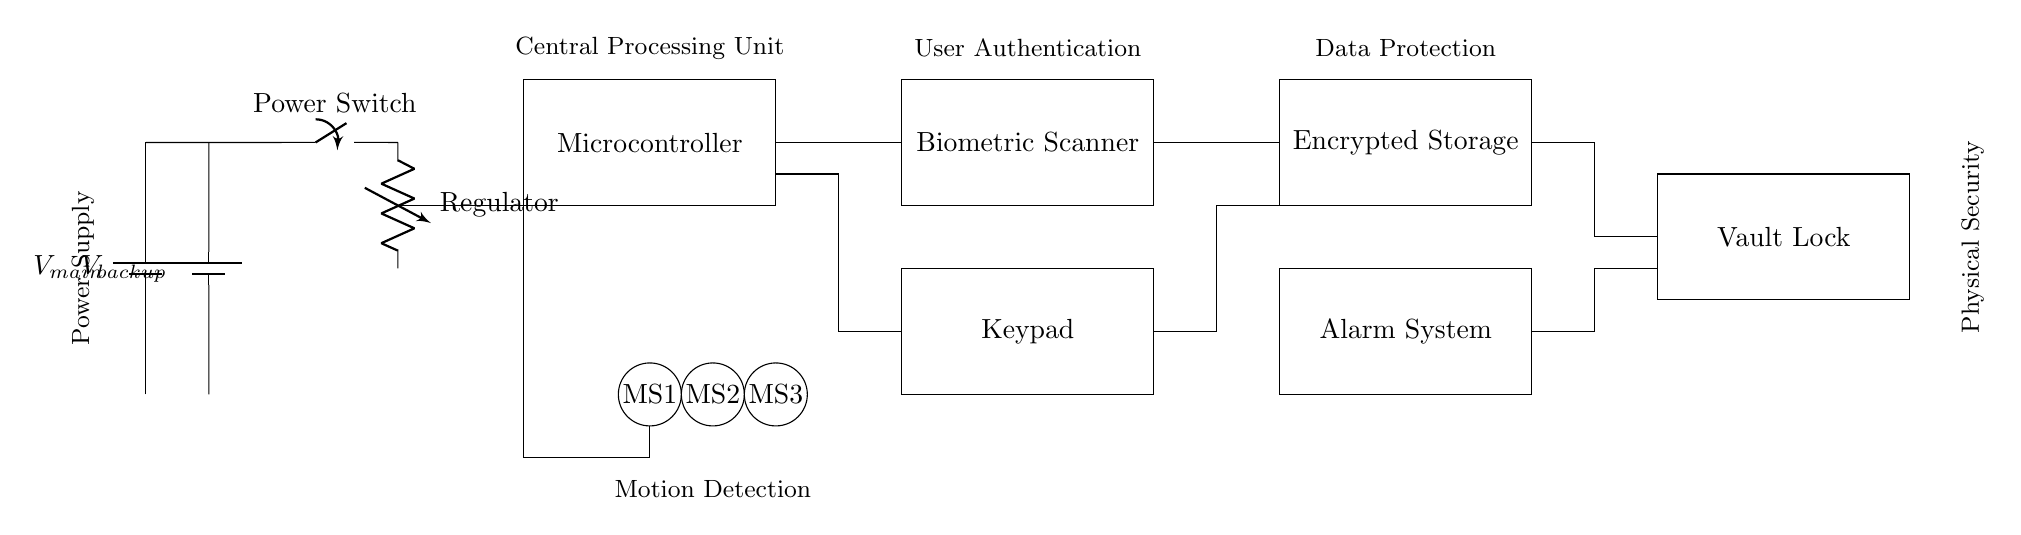What is the purpose of the microcontroller in this circuit? The microcontroller is used for processing and controlling the various components of the multi-layered security system, such as managing inputs from the biometric scanner and keypad, as well as dictating responses to authentication attempts.
Answer: Control and processing What are the two power supplies included in the circuit? The circuit diagram contains two power supplies, the main power supply and the backup power supply, which provide electrical energy to the entire system.
Answer: Main and backup How many motion sensors are present in this circuit? There are three motion sensors labeled as MS1, MS2, and MS3, which monitor movements in the vicinity of the vault.
Answer: Three Which component is responsible for user authentication? The biometric scanner is the component designed specifically for user authentication by verifying physical characteristics, such as fingerprints or facial recognition.
Answer: Biometric scanner What does the alarm system connect to in the circuit? The alarm system is connected to the encrypted storage and the vault lock, indicating that it activates when unauthorized access is detected and is integrated into the security features.
Answer: Encrypted storage and vault lock What kind of sensors are present in the circuit? The circuit includes motion sensors that are tasked with detecting movement, which are essential for triggering an alarm or alert in potential breach situations.
Answer: Motion sensors What component regulates the voltage in this circuit? The voltage regulator is responsible for ensuring that the connected components receive a stable and appropriate voltage level, which is critical for their operational integrity.
Answer: Regulator 